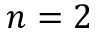<formula> <loc_0><loc_0><loc_500><loc_500>n = 2</formula> 